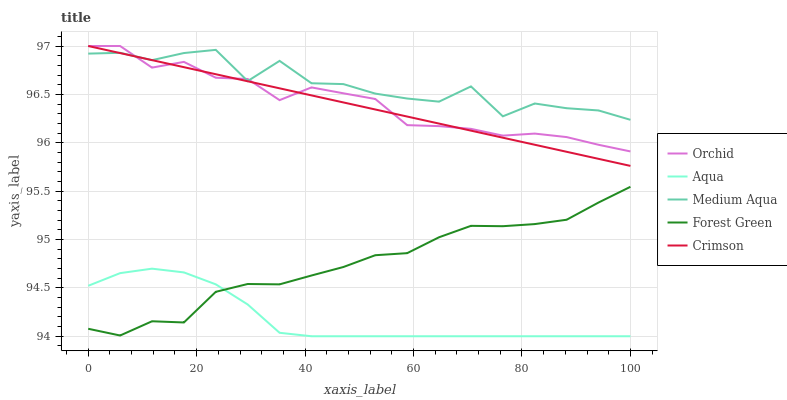Does Aqua have the minimum area under the curve?
Answer yes or no. Yes. Does Medium Aqua have the maximum area under the curve?
Answer yes or no. Yes. Does Forest Green have the minimum area under the curve?
Answer yes or no. No. Does Forest Green have the maximum area under the curve?
Answer yes or no. No. Is Crimson the smoothest?
Answer yes or no. Yes. Is Medium Aqua the roughest?
Answer yes or no. Yes. Is Forest Green the smoothest?
Answer yes or no. No. Is Forest Green the roughest?
Answer yes or no. No. Does Aqua have the lowest value?
Answer yes or no. Yes. Does Forest Green have the lowest value?
Answer yes or no. No. Does Orchid have the highest value?
Answer yes or no. Yes. Does Medium Aqua have the highest value?
Answer yes or no. No. Is Forest Green less than Medium Aqua?
Answer yes or no. Yes. Is Orchid greater than Aqua?
Answer yes or no. Yes. Does Medium Aqua intersect Crimson?
Answer yes or no. Yes. Is Medium Aqua less than Crimson?
Answer yes or no. No. Is Medium Aqua greater than Crimson?
Answer yes or no. No. Does Forest Green intersect Medium Aqua?
Answer yes or no. No. 